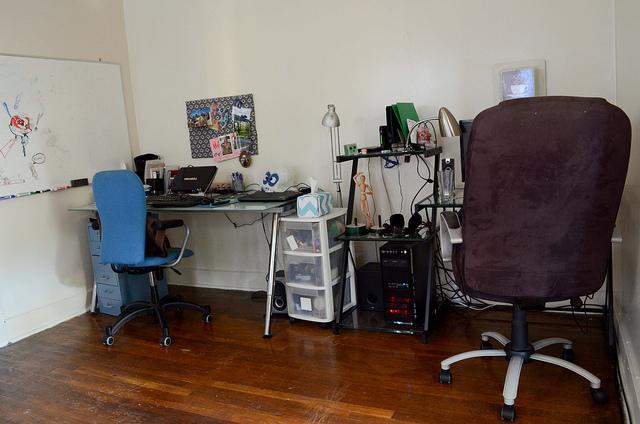Is this a home office?
Short answer required. Yes. How many chairs are there?
Concise answer only. 2. What kind of flooring is in this room?
Answer briefly. Wood. 